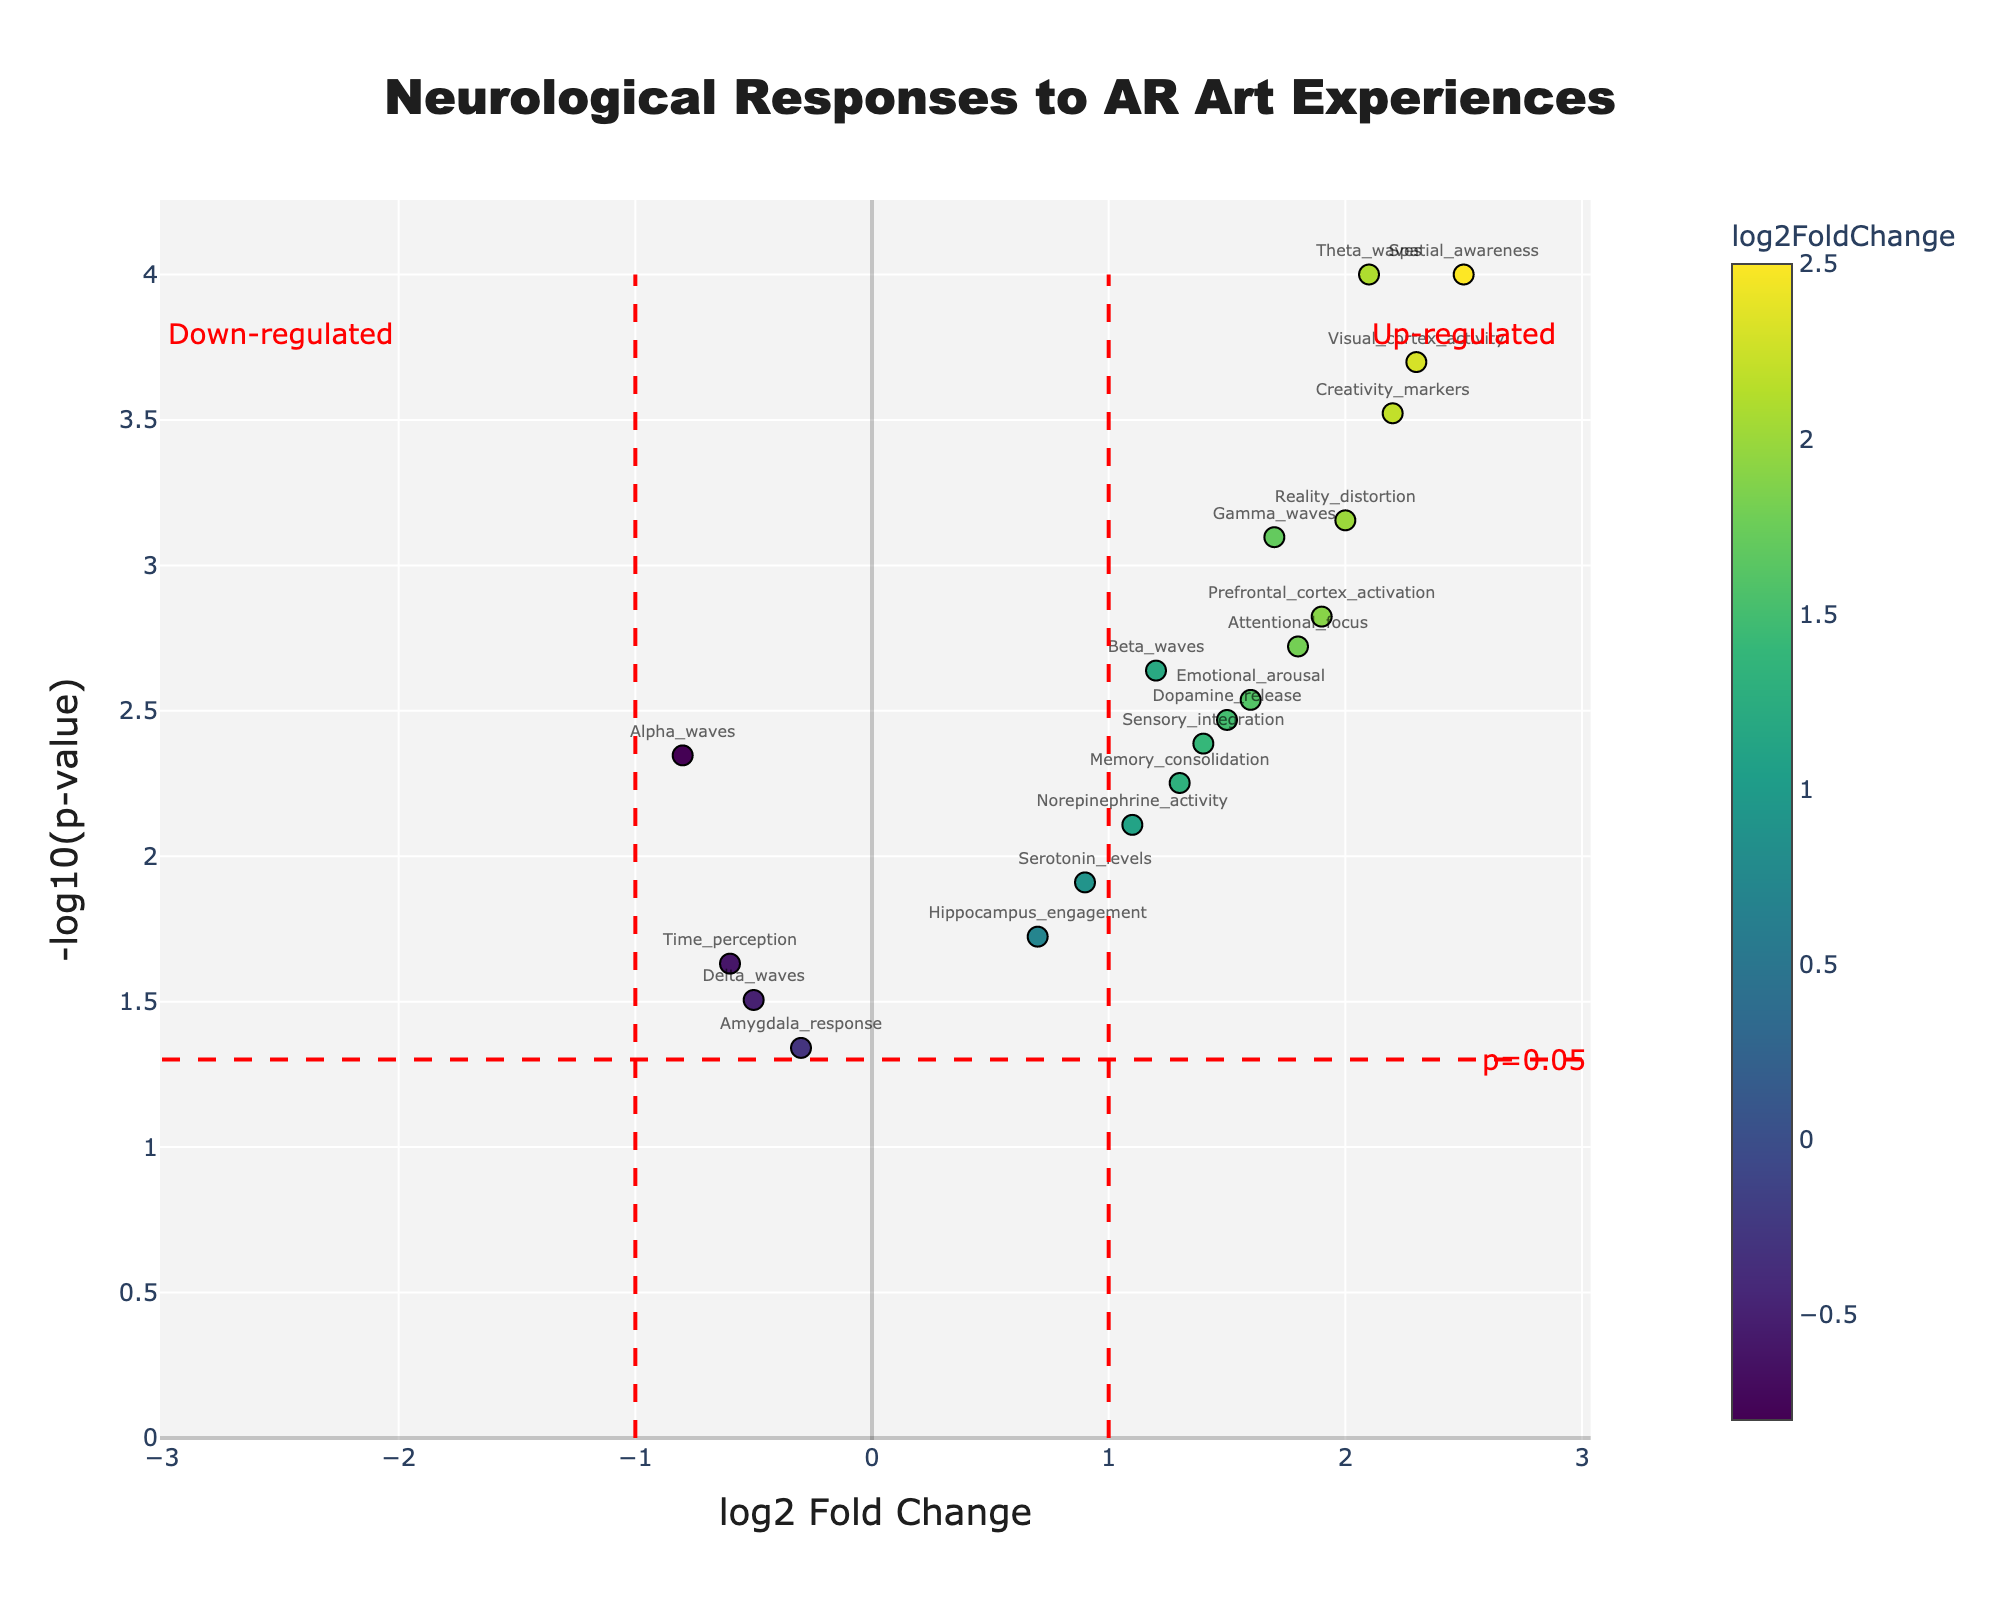What is the title of the plot? The title of the plot is located at the top center of the figure. By reading it, we can see that the title is "Neurological Responses to AR Art Experiences".
Answer: Neurological Responses to AR Art Experiences How many data points have a log2 Fold Change greater than 2? By looking at the x-axis values, we can identify data points with a log2 Fold Change greater than 2. These are Theta_waves, Visual_cortex_activity, Spatial_awareness, and Creativity_markers.
Answer: 4 Which neurological response shows the highest -log10(p-value)? To find this, we locate the highest point on the y-axis. The label at this highest point will give us the name of the response, which is Theta_waves.
Answer: Theta_waves How many data points lie within the up-regulated region? The up-regulated region is defined as having a log2 Fold Change greater than 1, on the right of the vertical red dashed line at log2 Fold Change of 1. Count the data points that fall within this region: Theta_waves, Visual_cortex_activity, Creativity_markers, Reality_distortion, Spatial_awareness, Prefrontal_cortex_activation, Gamma_waves, Attentional_focus, Emotional_arousal, Norepinephrine_activity, Beta_waves, Sensory_integration, Dopamine_release, and Memory_consolidation.
Answer: 14 Which neurological response has the lowest log2 Fold Change? To find the lowest log2 Fold Change, we look for the leftmost point on the x-axis. The label at this point indicates that Time_perception has the lowest log2 Fold Change.
Answer: Time_perception What is the significance threshold indicated on the plot? The significance threshold line is the horizontal red dashed line, which represents a p-value of 0.05. On the plot, this corresponds to a -log10(p-value) of approximately 1.3.
Answer: 0.05 Which data points are exactly on the significance threshold? Data points on the significance threshold are those lying exactly on the red dashed horizontal line at -log10(p-value) = 1.3. Identifying this from the plot, we see that it corresponds to p-value=0.05 for the gene Delta_waves and Time_perception.
Answer: Delta_waves, Time_perception How many data points have a log2 Fold Change less than -1? Data points with a log2 Fold Change less than -1 are to the left of the vertical red dashed line at -1. In this plot, there are no data points in this region.
Answer: 0 Which two data points have log2 Fold Changes closest to 0? To find the data points closest to 0 on the x-axis, we look at the points nearest to the center. The closest data point labels are Amygdala_response and Delta_waves.
Answer: Amygdala_response, Delta_waves 